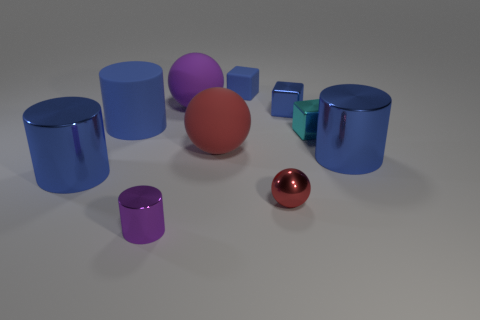Subtract all large blue cylinders. How many cylinders are left? 1 Subtract all blue cylinders. How many cylinders are left? 1 Subtract 2 blue cylinders. How many objects are left? 8 Subtract all spheres. How many objects are left? 7 Subtract 3 cylinders. How many cylinders are left? 1 Subtract all green spheres. Subtract all cyan cylinders. How many spheres are left? 3 Subtract all yellow blocks. How many brown spheres are left? 0 Subtract all metal spheres. Subtract all tiny purple metal cylinders. How many objects are left? 8 Add 3 large things. How many large things are left? 8 Add 5 cyan balls. How many cyan balls exist? 5 